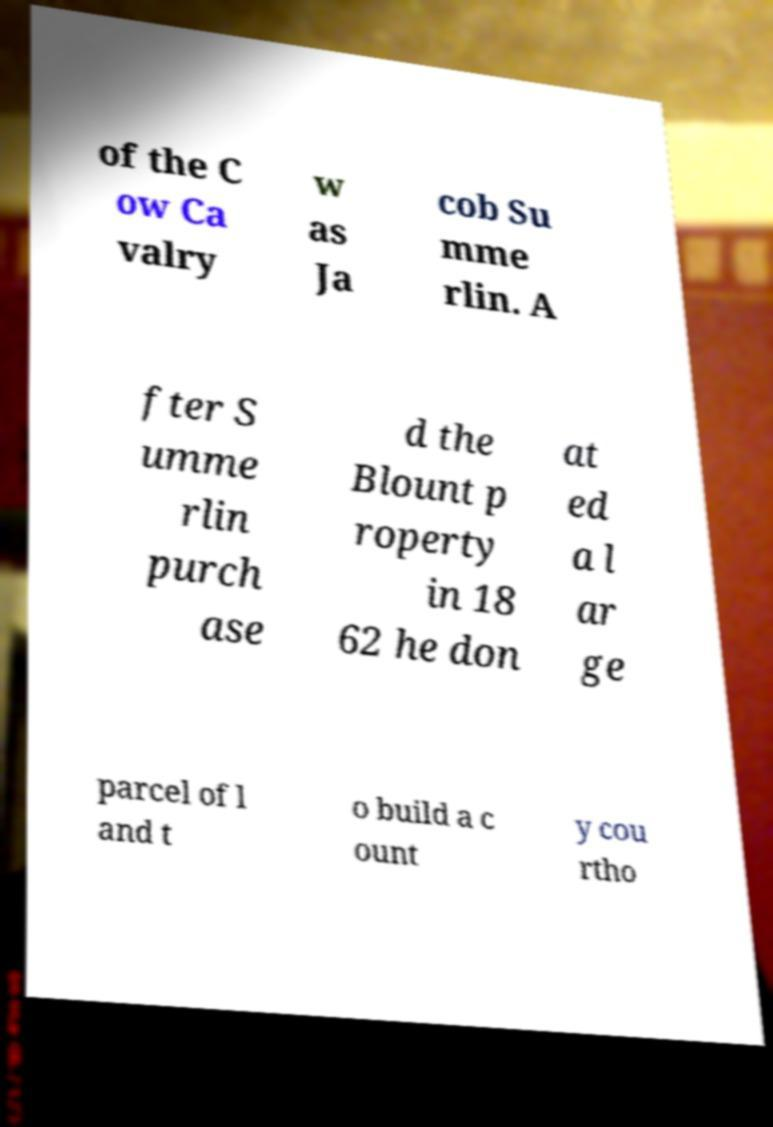Could you assist in decoding the text presented in this image and type it out clearly? of the C ow Ca valry w as Ja cob Su mme rlin. A fter S umme rlin purch ase d the Blount p roperty in 18 62 he don at ed a l ar ge parcel of l and t o build a c ount y cou rtho 